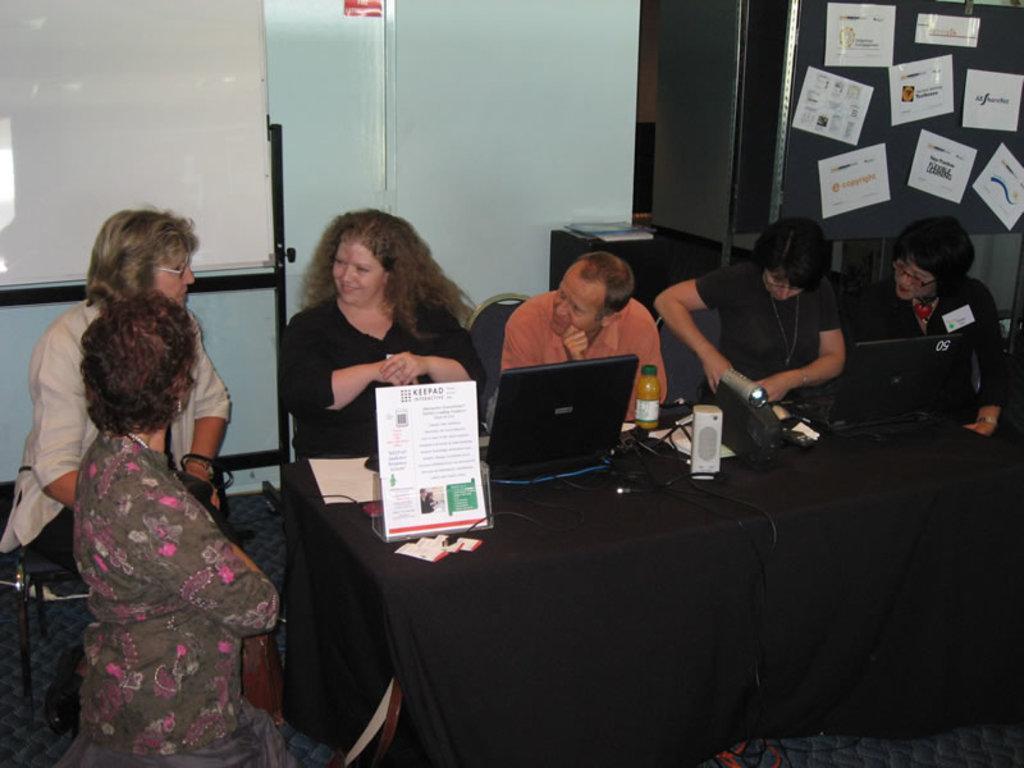Can you describe this image briefly? As we can see in the image there is a wall, almirah, few people sitting on chairs and there is a table. On table there is a poster and laptop. 